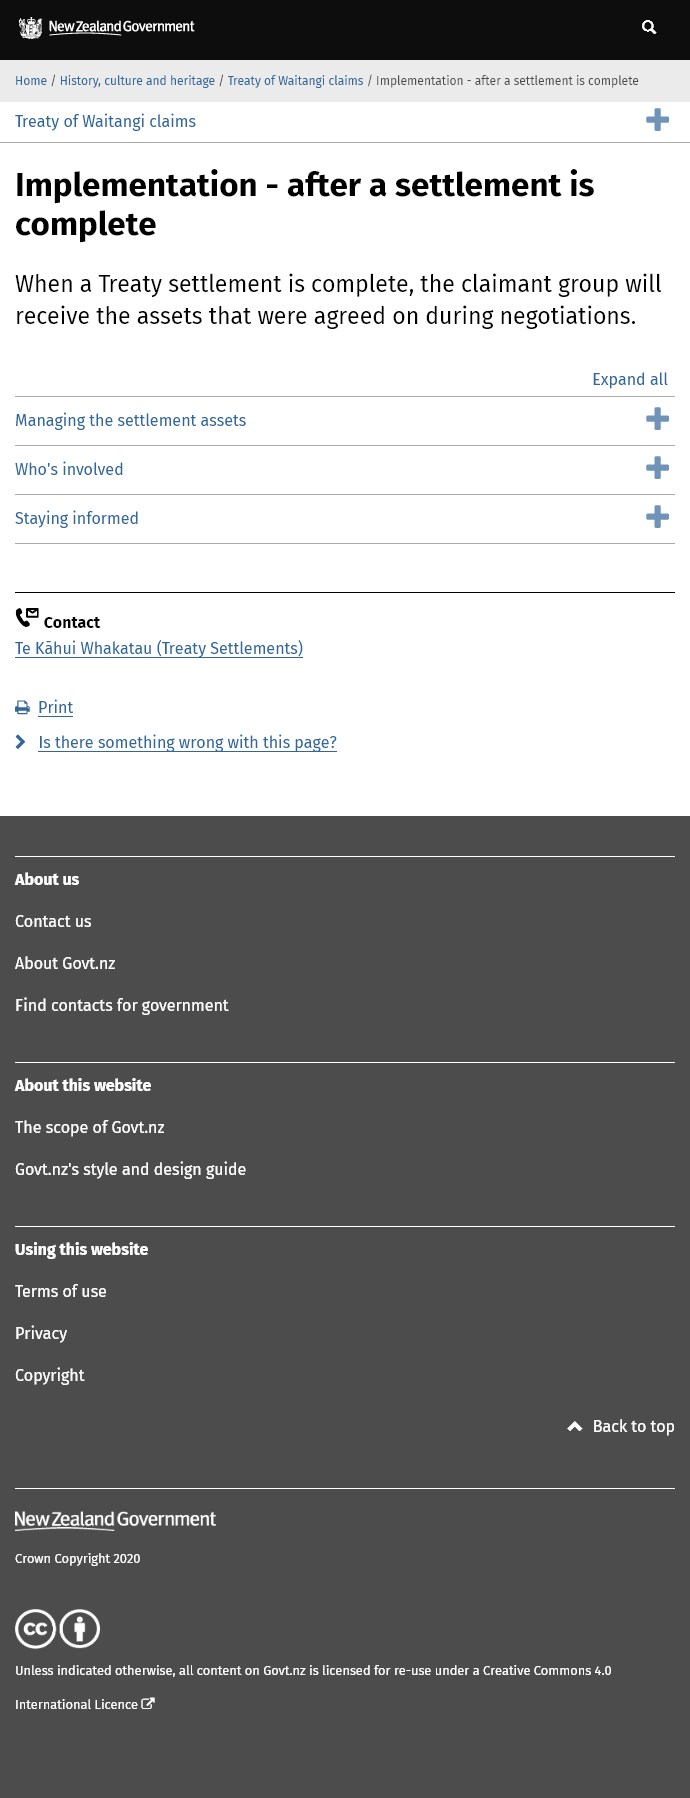Outline some significant characteristics in this image. The implementation of the settlement will commence after the completion of the settlement. After a treaty settlement is completed, the claimant group will receive the assets. The website provides additional information regarding the settlement, including the management of its assets, the individuals involved, and methods for staying informed. 